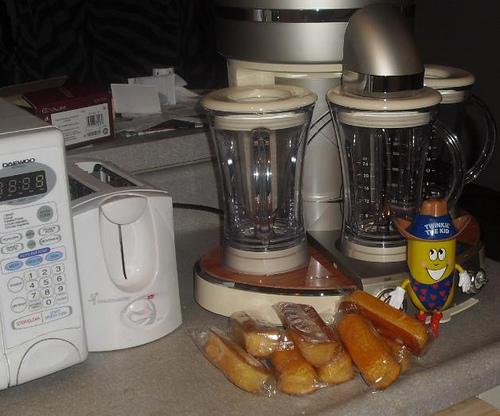What appliance is pictured on the right?
Short answer required. Blender. What color is the middle blender?
Concise answer only. Beige. What is the color of the blenders base?
Quick response, please. White. What are we cooking up for breakfast this morning?
Concise answer only. Twinkies. What color is the handle?
Short answer required. Clear. What color is the blender?
Answer briefly. Beige. What brand is the doll a mascot for?
Answer briefly. Hostess. How many blenders?
Keep it brief. 3. Do any of these kitchen appliances appear to be in use at the time of the photo?
Be succinct. No. What color is the microwave?
Write a very short answer. White. 